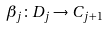<formula> <loc_0><loc_0><loc_500><loc_500>\beta _ { j } \colon D _ { j } \rightarrow C _ { j + 1 }</formula> 